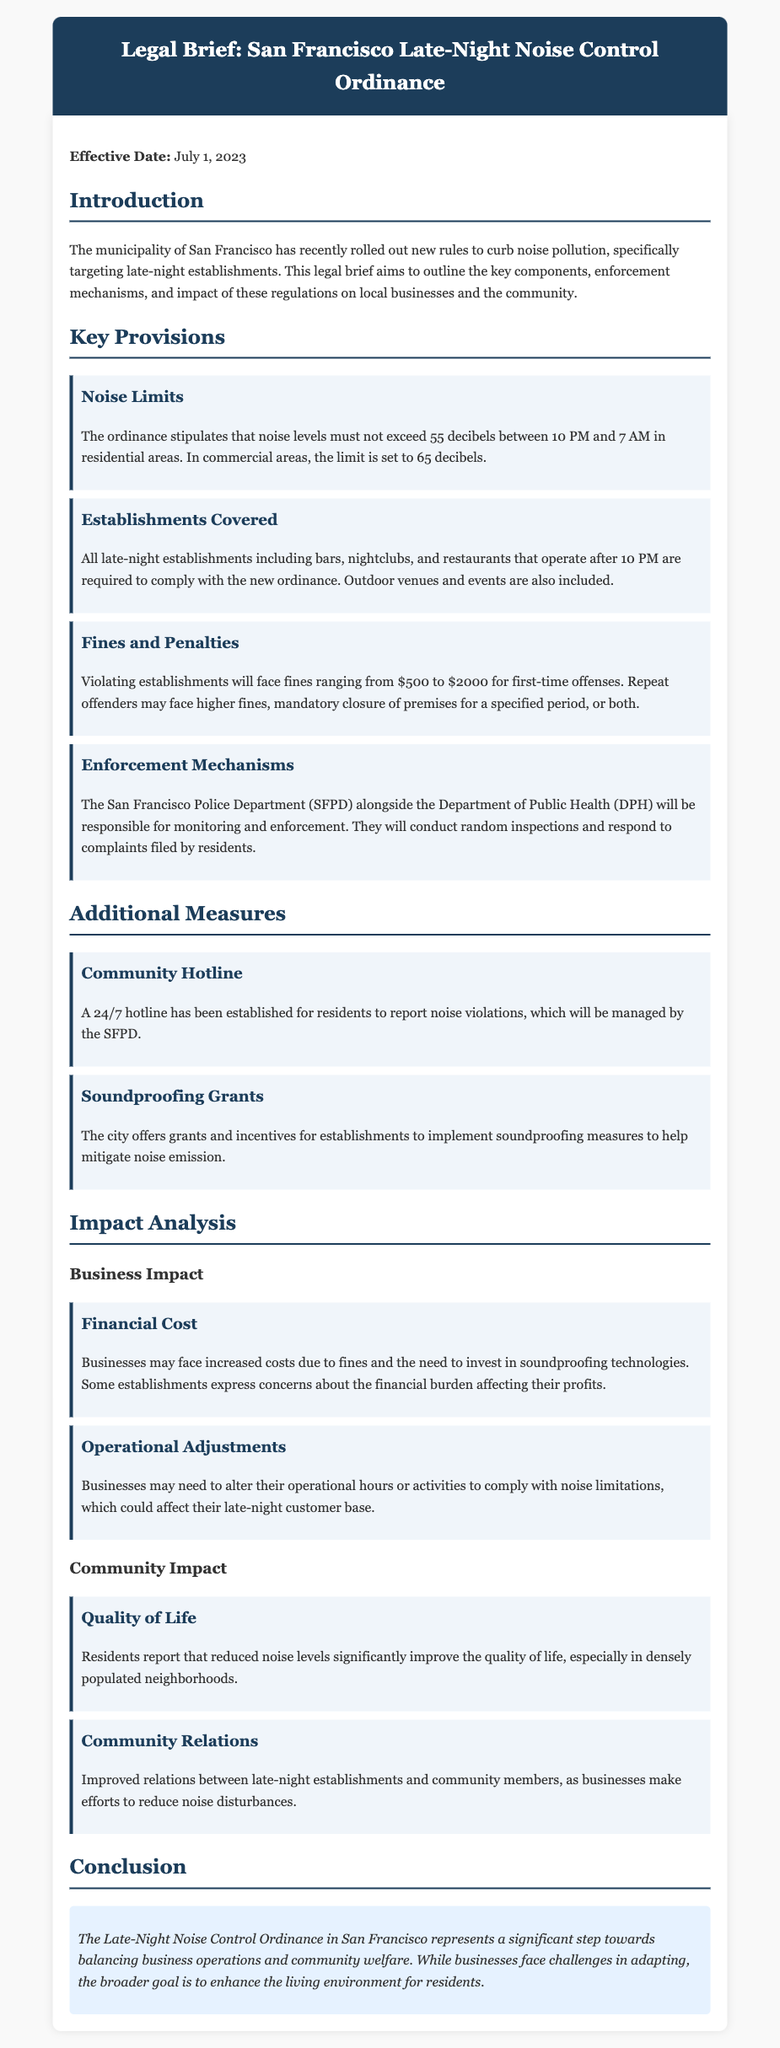What is the effective date of the ordinance? The effective date of the ordinance is mentioned at the beginning of the document.
Answer: July 1, 2023 What are the noise limits for residential areas? The document specifies the noise limit for residential areas.
Answer: 55 decibels Which establishments are required to comply with the ordinance? The provision lists the types of establishments affected by the ordinance.
Answer: Bars, nightclubs, and restaurants What is the range of fines for first-time offenses? The document outlines the fines and penalties for violations.
Answer: $500 to $2000 Who is responsible for enforcing the noise control ordinance? The enforcement mechanisms section specifies which departments will enforce the ordinance.
Answer: San Francisco Police Department and Department of Public Health How does the community report noise violations? The additional measures section describes the reporting mechanism for residents.
Answer: 24/7 hotline What financial effect might businesses experience due to the ordinance? The impact analysis section discusses potential costs for businesses.
Answer: Increased costs What is one benefit to the community from reduced noise levels? The community impact section highlights the advantages of lowered noise levels.
Answer: Quality of life What does the ordinance aim to balance? The conclusion summarizes the goals of the ordinance.
Answer: Business operations and community welfare 